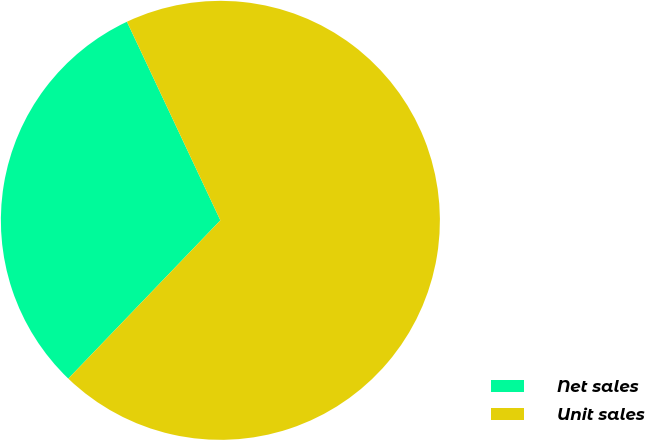<chart> <loc_0><loc_0><loc_500><loc_500><pie_chart><fcel>Net sales<fcel>Unit sales<nl><fcel>30.82%<fcel>69.18%<nl></chart> 